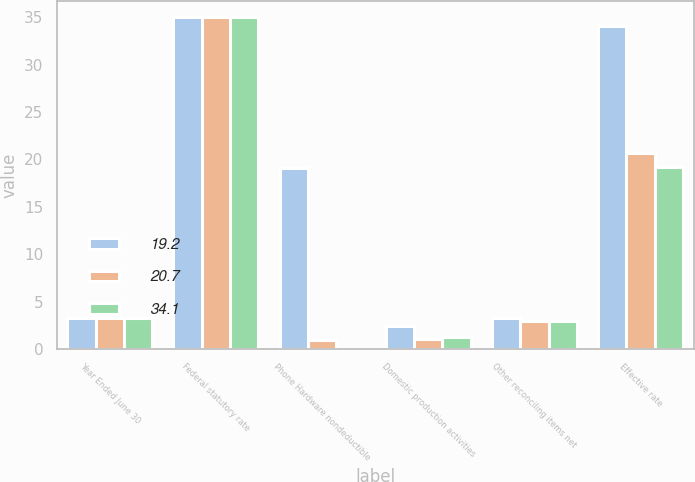Convert chart to OTSL. <chart><loc_0><loc_0><loc_500><loc_500><stacked_bar_chart><ecel><fcel>Year Ended June 30<fcel>Federal statutory rate<fcel>Phone Hardware nondeductible<fcel>Domestic production activities<fcel>Other reconciling items net<fcel>Effective rate<nl><fcel>19.2<fcel>3.3<fcel>35<fcel>19.1<fcel>2.4<fcel>3.3<fcel>34.1<nl><fcel>20.7<fcel>3.3<fcel>35<fcel>0.9<fcel>1<fcel>2.9<fcel>20.7<nl><fcel>34.1<fcel>3.3<fcel>35<fcel>0<fcel>1.2<fcel>2.9<fcel>19.2<nl></chart> 